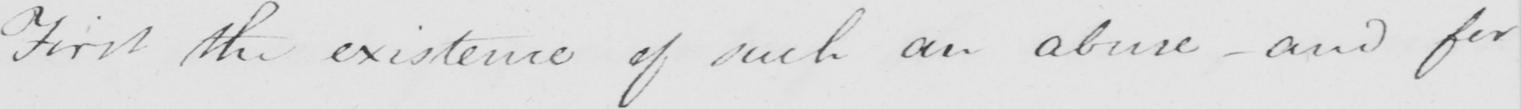Please transcribe the handwritten text in this image. First the existence of such an abuse  _  and for 